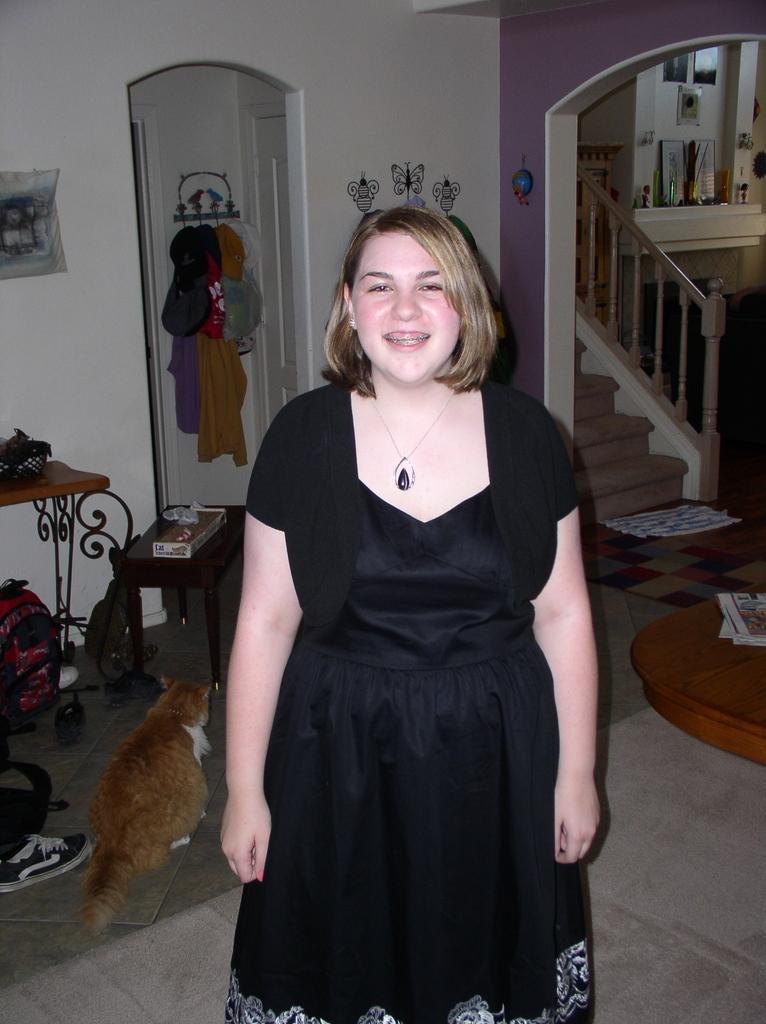Please provide a concise description of this image. This is the picture of a lady wearing a black color gown and has short hair and behind her there is a cat, a desk on which some things are placed, staircase and some things placed. 